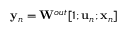<formula> <loc_0><loc_0><loc_500><loc_500>{ y } _ { n } = { W } ^ { o u t } [ 1 ; { u } _ { n } ; { x } _ { n } ]</formula> 